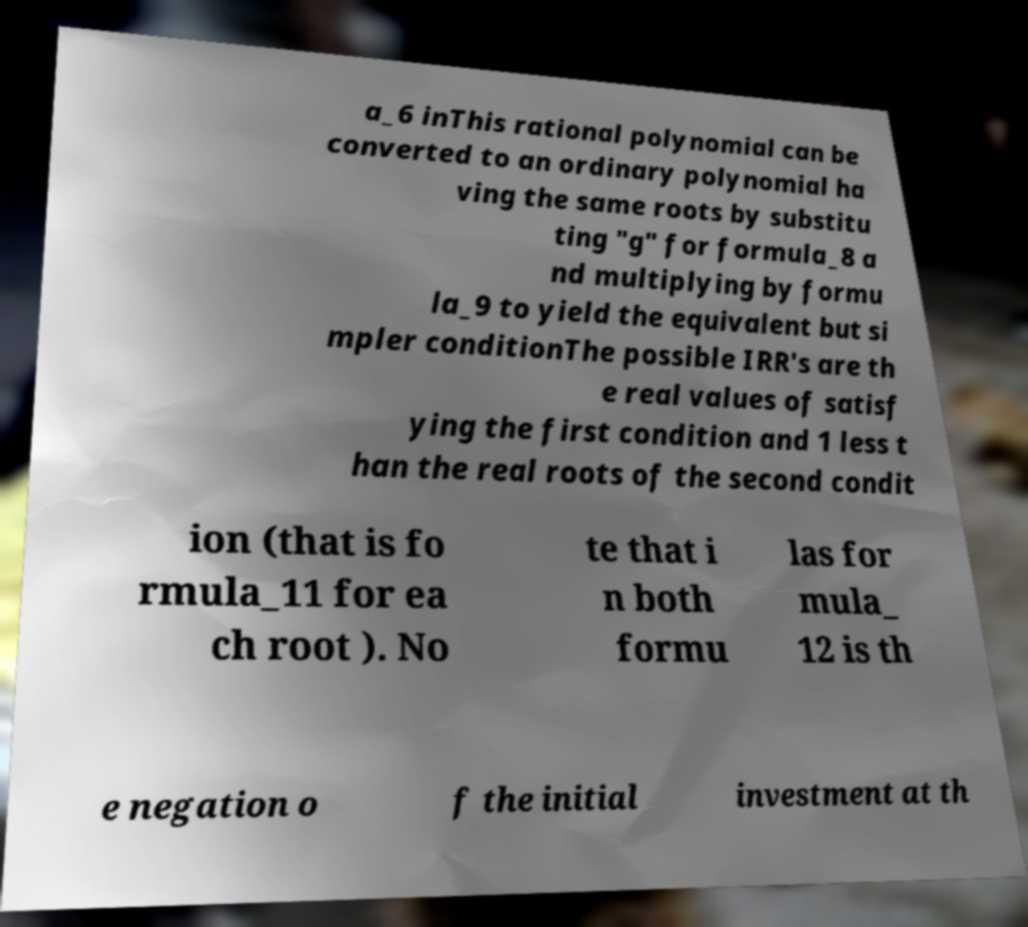What messages or text are displayed in this image? I need them in a readable, typed format. a_6 inThis rational polynomial can be converted to an ordinary polynomial ha ving the same roots by substitu ting "g" for formula_8 a nd multiplying by formu la_9 to yield the equivalent but si mpler conditionThe possible IRR's are th e real values of satisf ying the first condition and 1 less t han the real roots of the second condit ion (that is fo rmula_11 for ea ch root ). No te that i n both formu las for mula_ 12 is th e negation o f the initial investment at th 